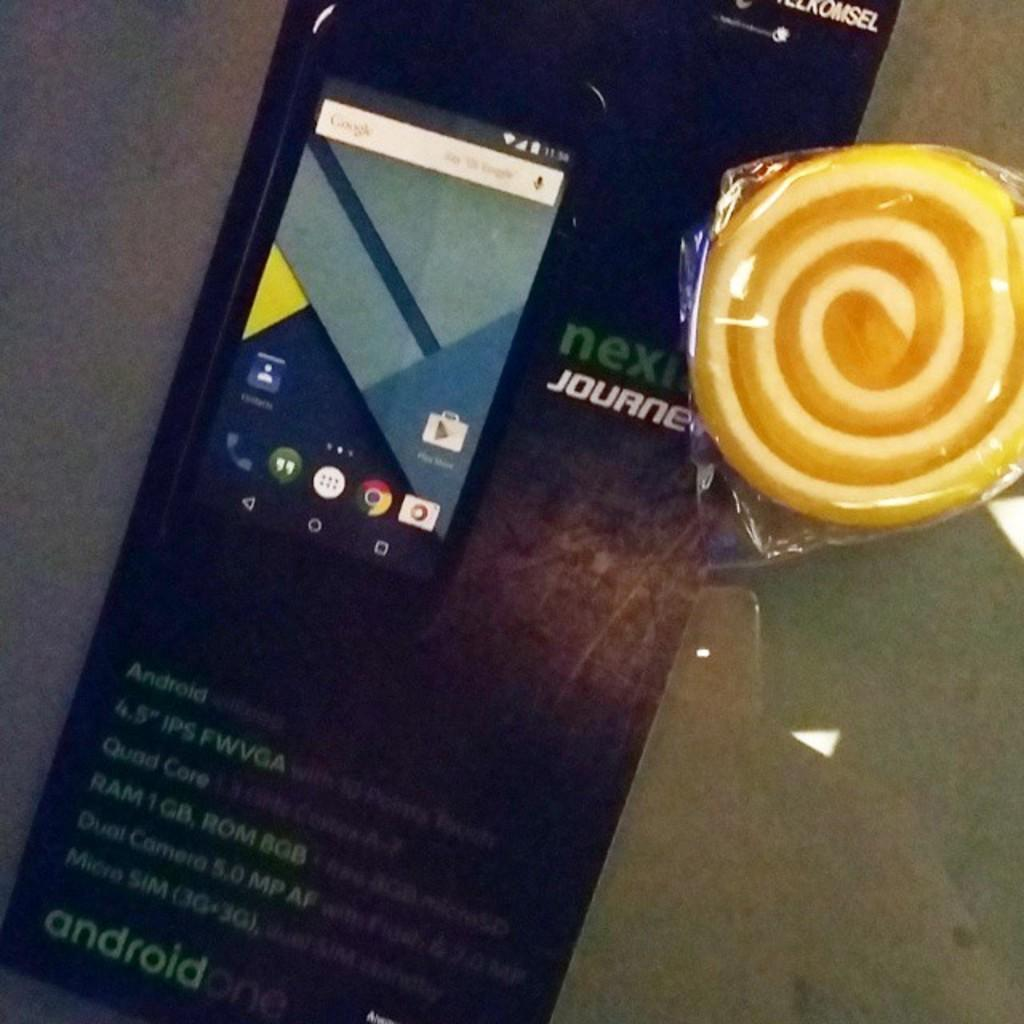<image>
Offer a succinct explanation of the picture presented. A  box for an android one smartphone with phone 